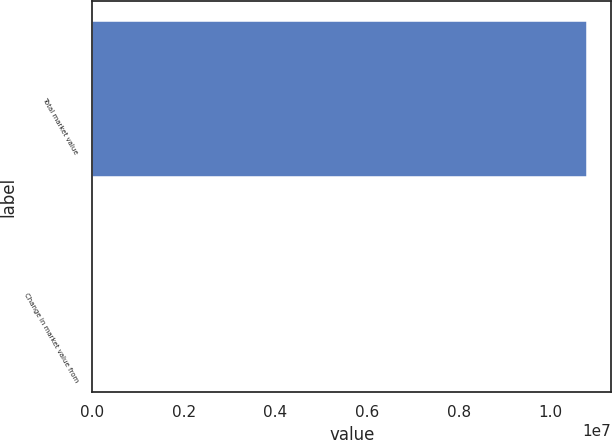Convert chart. <chart><loc_0><loc_0><loc_500><loc_500><bar_chart><fcel>Total market value<fcel>Change in market value from<nl><fcel>1.07846e+07<fcel>3.65<nl></chart> 